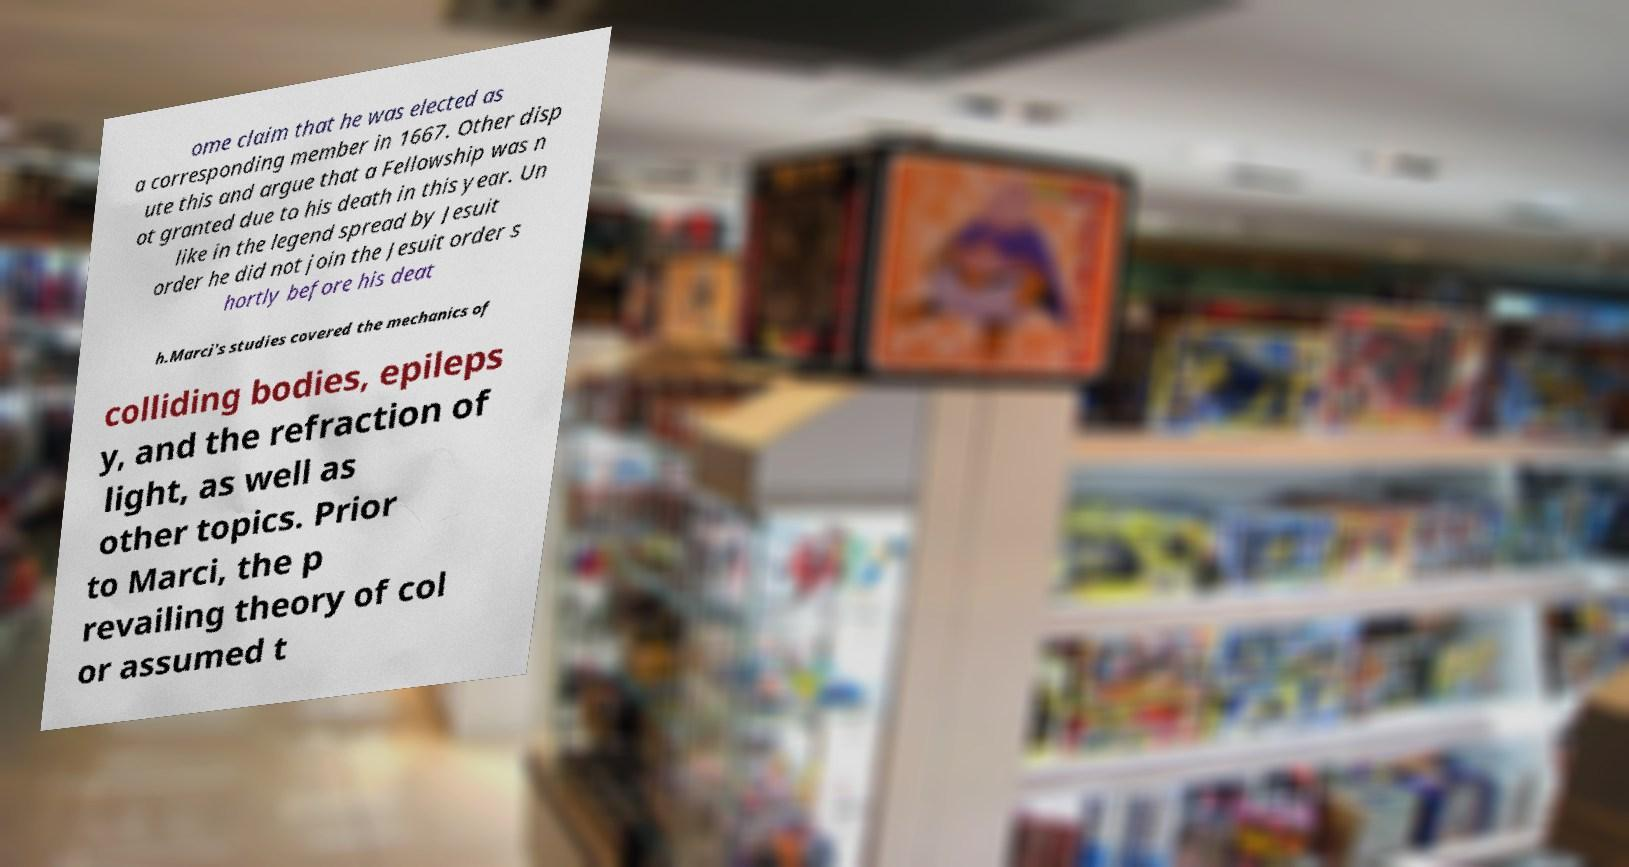What messages or text are displayed in this image? I need them in a readable, typed format. ome claim that he was elected as a corresponding member in 1667. Other disp ute this and argue that a Fellowship was n ot granted due to his death in this year. Un like in the legend spread by Jesuit order he did not join the Jesuit order s hortly before his deat h.Marci's studies covered the mechanics of colliding bodies, epileps y, and the refraction of light, as well as other topics. Prior to Marci, the p revailing theory of col or assumed t 